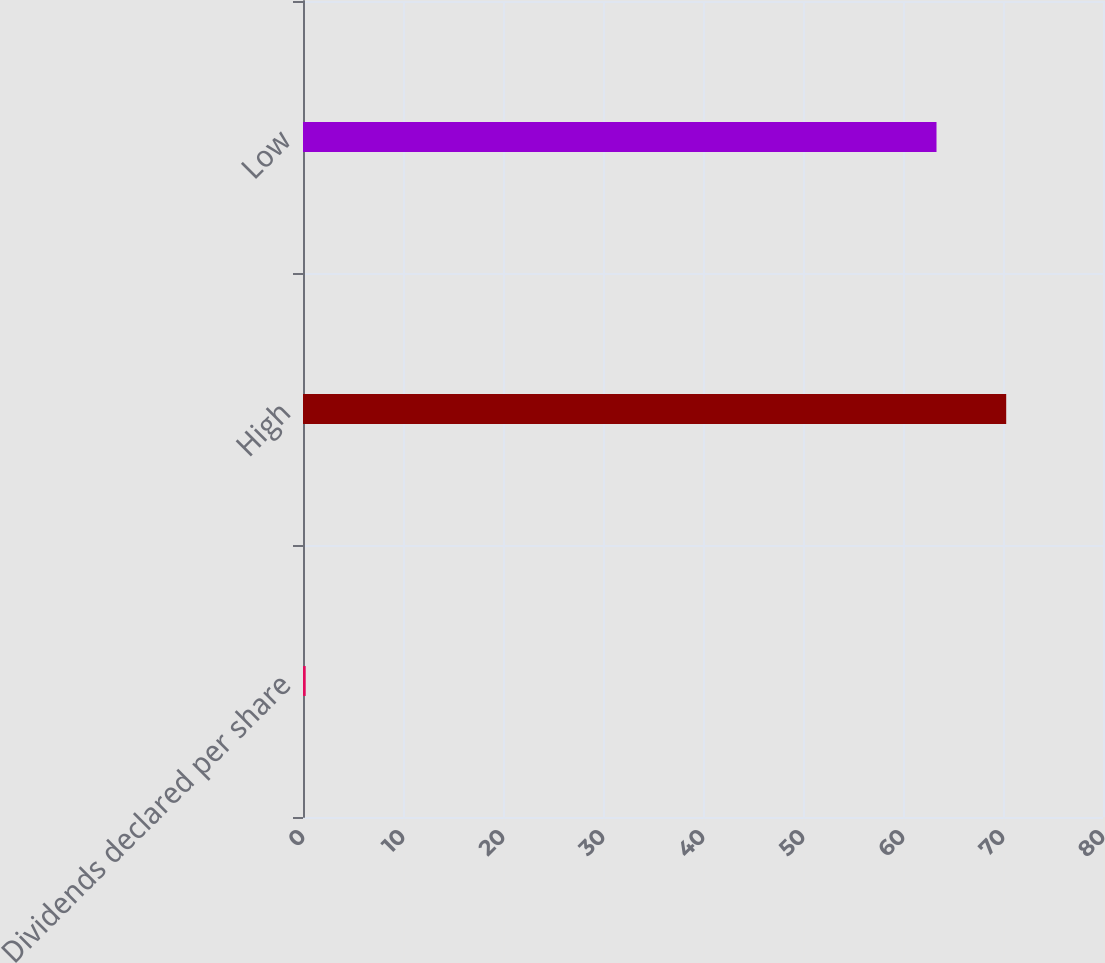Convert chart. <chart><loc_0><loc_0><loc_500><loc_500><bar_chart><fcel>Dividends declared per share<fcel>High<fcel>Low<nl><fcel>0.27<fcel>70.32<fcel>63.35<nl></chart> 